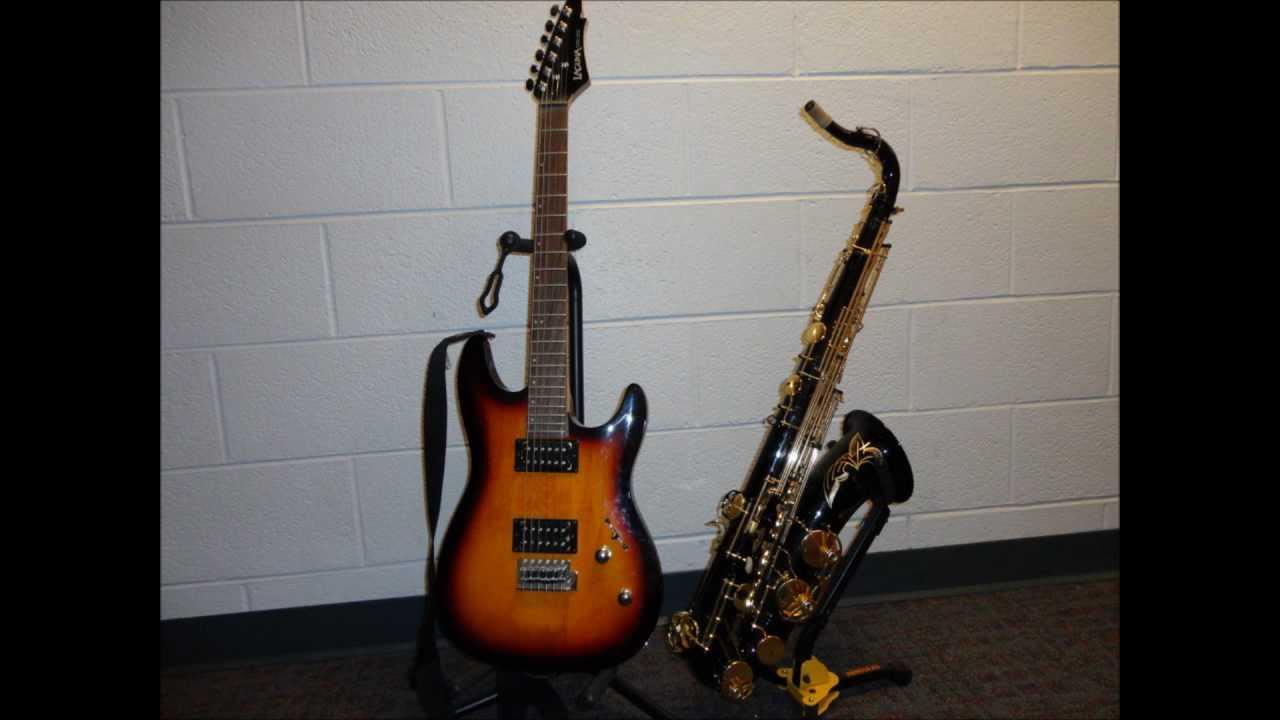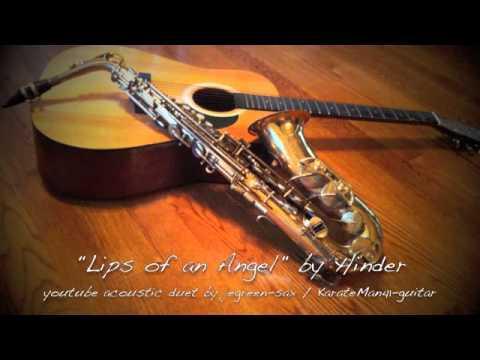The first image is the image on the left, the second image is the image on the right. Considering the images on both sides, is "The left and right image contains the same number of saxophones and guitars." valid? Answer yes or no. Yes. The first image is the image on the left, the second image is the image on the right. Considering the images on both sides, is "There are two saxophones and one guitar" valid? Answer yes or no. No. 